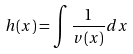<formula> <loc_0><loc_0><loc_500><loc_500>h ( x ) = \int \frac { 1 } { v ( x ) } d x</formula> 